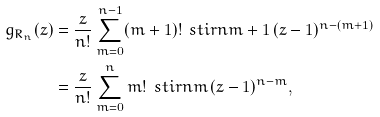<formula> <loc_0><loc_0><loc_500><loc_500>g _ { R _ { n } } ( z ) & = \frac { z } { n ! } \sum _ { m = 0 } ^ { n - 1 } ( m + 1 ) ! \, \ s t i r n { m + 1 } \, ( z - 1 ) ^ { n - ( m + 1 ) } \\ & = \frac { z } { n ! } \sum _ { m = 0 } ^ { n } m ! \, \ s t i r n m \, ( z - 1 ) ^ { n - m } ,</formula> 